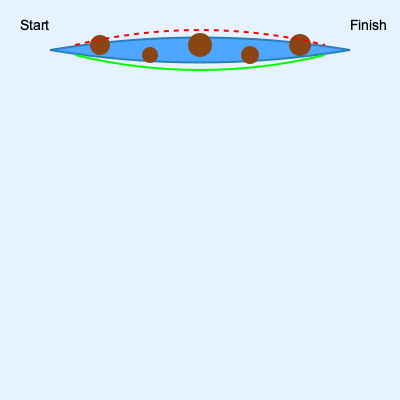Based on the top-down view of a river section with obstacles, which route would you recommend for a kayaker to safely navigate through the rapids? To determine the optimal route through this river section, we need to consider several factors:

1. Obstacle placement: The brown circles represent rocks or other obstacles in the river.
2. River flow: The blue area represents the river, with the curved shape indicating the flow direction and potential currents.
3. Available routes: Two potential routes are shown - a red dashed line (upper route) and a green solid line (lower route).

Analyzing the routes:

1. Upper route (red dashed line):
   - Passes very close to multiple obstacles
   - Follows the outer curve of the river, where water velocity is typically higher
   - May require more challenging maneuvering due to proximity to obstacles and potential higher speed

2. Lower route (green solid line):
   - Maintains a safer distance from most obstacles
   - Follows the inner curve of the river, where water velocity is typically lower
   - Provides more room for maneuvering and error correction

As a kayaking instructor, the primary concern is safety while navigating challenging rapids. The lower route offers several advantages:

1. Increased safety margin from obstacles
2. Potentially slower water speed, allowing for better control
3. More space for corrective actions if needed

While the upper route might be faster due to potentially higher water velocity, it poses more risks and requires more advanced skills to navigate safely.
Answer: Lower route (green line) 